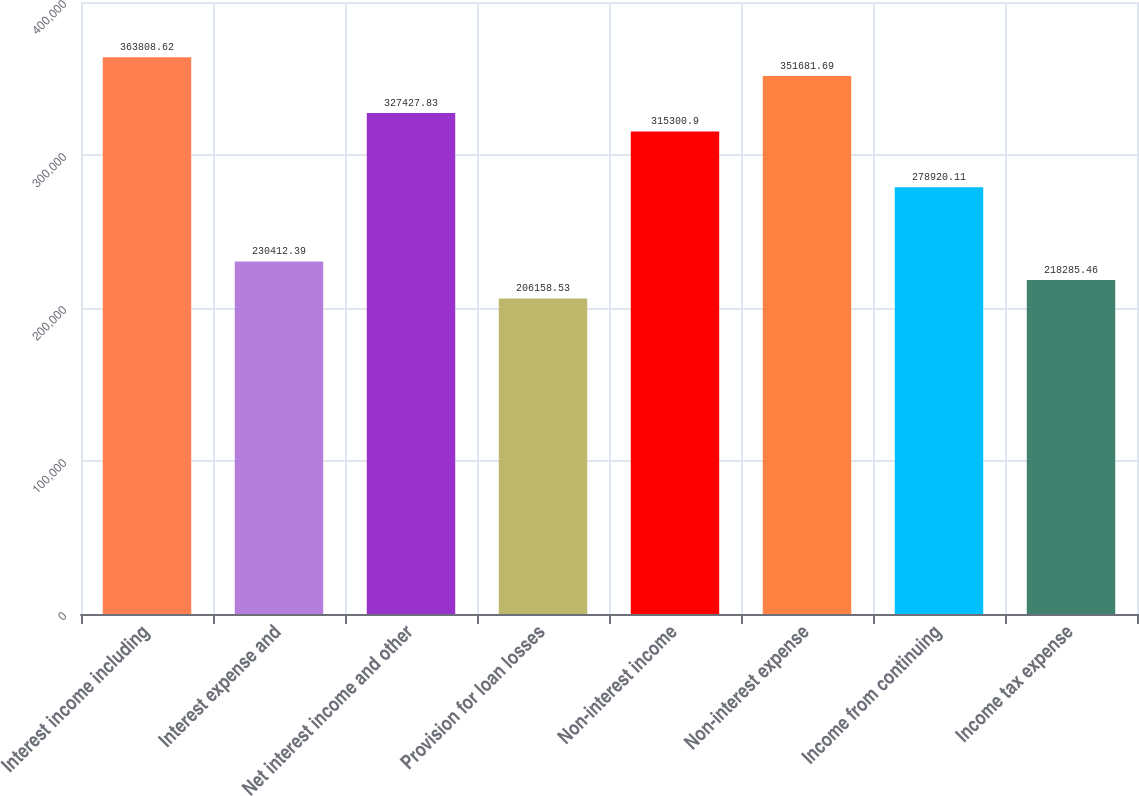<chart> <loc_0><loc_0><loc_500><loc_500><bar_chart><fcel>Interest income including<fcel>Interest expense and<fcel>Net interest income and other<fcel>Provision for loan losses<fcel>Non-interest income<fcel>Non-interest expense<fcel>Income from continuing<fcel>Income tax expense<nl><fcel>363809<fcel>230412<fcel>327428<fcel>206159<fcel>315301<fcel>351682<fcel>278920<fcel>218285<nl></chart> 